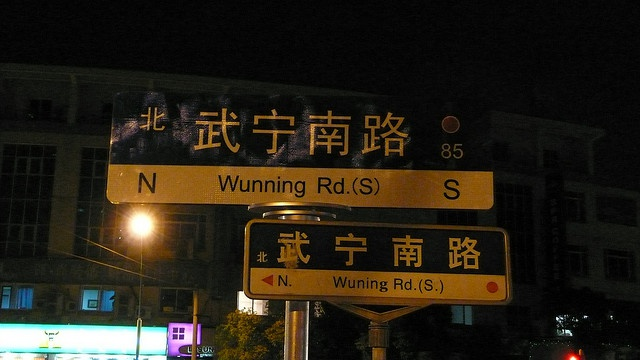Describe the objects in this image and their specific colors. I can see a traffic light in black, maroon, and red tones in this image. 